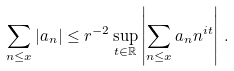<formula> <loc_0><loc_0><loc_500><loc_500>\sum _ { n \leq x } | a _ { n } | \leq r ^ { - 2 } \sup _ { t \in \mathbb { R } } \left | \sum _ { n \leq x } a _ { n } n ^ { i t } \right | \, .</formula> 